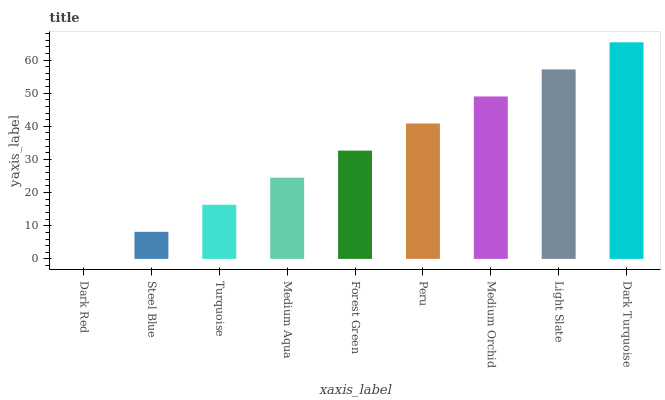Is Steel Blue the minimum?
Answer yes or no. No. Is Steel Blue the maximum?
Answer yes or no. No. Is Steel Blue greater than Dark Red?
Answer yes or no. Yes. Is Dark Red less than Steel Blue?
Answer yes or no. Yes. Is Dark Red greater than Steel Blue?
Answer yes or no. No. Is Steel Blue less than Dark Red?
Answer yes or no. No. Is Forest Green the high median?
Answer yes or no. Yes. Is Forest Green the low median?
Answer yes or no. Yes. Is Dark Red the high median?
Answer yes or no. No. Is Medium Aqua the low median?
Answer yes or no. No. 